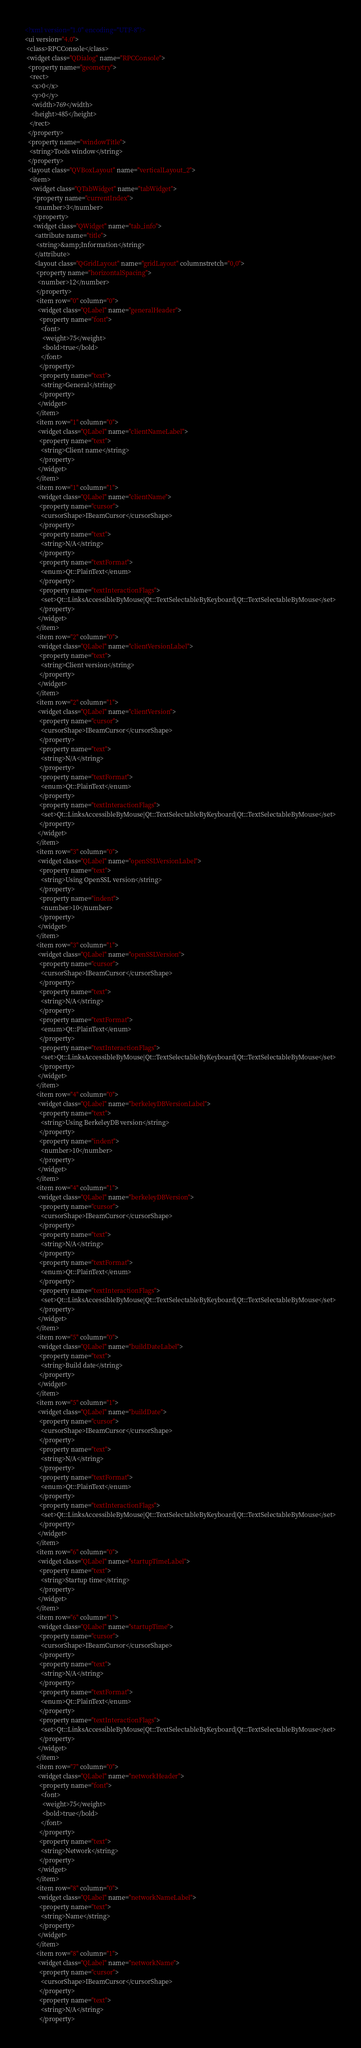<code> <loc_0><loc_0><loc_500><loc_500><_XML_><?xml version="1.0" encoding="UTF-8"?>
<ui version="4.0">
 <class>RPCConsole</class>
 <widget class="QDialog" name="RPCConsole">
  <property name="geometry">
   <rect>
    <x>0</x>
    <y>0</y>
    <width>769</width>
    <height>485</height>
   </rect>
  </property>
  <property name="windowTitle">
   <string>Tools window</string>
  </property>
  <layout class="QVBoxLayout" name="verticalLayout_2">
   <item>
    <widget class="QTabWidget" name="tabWidget">
     <property name="currentIndex">
      <number>3</number>
     </property>
     <widget class="QWidget" name="tab_info">
      <attribute name="title">
       <string>&amp;Information</string>
      </attribute>
      <layout class="QGridLayout" name="gridLayout" columnstretch="0,0">
       <property name="horizontalSpacing">
        <number>12</number>
       </property>
       <item row="0" column="0">
        <widget class="QLabel" name="generalHeader">
         <property name="font">
          <font>
           <weight>75</weight>
           <bold>true</bold>
          </font>
         </property>
         <property name="text">
          <string>General</string>
         </property>
        </widget>
       </item>
       <item row="1" column="0">
        <widget class="QLabel" name="clientNameLabel">
         <property name="text">
          <string>Client name</string>
         </property>
        </widget>
       </item>
       <item row="1" column="1">
        <widget class="QLabel" name="clientName">
         <property name="cursor">
          <cursorShape>IBeamCursor</cursorShape>
         </property>
         <property name="text">
          <string>N/A</string>
         </property>
         <property name="textFormat">
          <enum>Qt::PlainText</enum>
         </property>
         <property name="textInteractionFlags">
          <set>Qt::LinksAccessibleByMouse|Qt::TextSelectableByKeyboard|Qt::TextSelectableByMouse</set>
         </property>
        </widget>
       </item>
       <item row="2" column="0">
        <widget class="QLabel" name="clientVersionLabel">
         <property name="text">
          <string>Client version</string>
         </property>
        </widget>
       </item>
       <item row="2" column="1">
        <widget class="QLabel" name="clientVersion">
         <property name="cursor">
          <cursorShape>IBeamCursor</cursorShape>
         </property>
         <property name="text">
          <string>N/A</string>
         </property>
         <property name="textFormat">
          <enum>Qt::PlainText</enum>
         </property>
         <property name="textInteractionFlags">
          <set>Qt::LinksAccessibleByMouse|Qt::TextSelectableByKeyboard|Qt::TextSelectableByMouse</set>
         </property>
        </widget>
       </item>
       <item row="3" column="0">
        <widget class="QLabel" name="openSSLVersionLabel">
         <property name="text">
          <string>Using OpenSSL version</string>
         </property>
         <property name="indent">
          <number>10</number>
         </property>
        </widget>
       </item>
       <item row="3" column="1">
        <widget class="QLabel" name="openSSLVersion">
         <property name="cursor">
          <cursorShape>IBeamCursor</cursorShape>
         </property>
         <property name="text">
          <string>N/A</string>
         </property>
         <property name="textFormat">
          <enum>Qt::PlainText</enum>
         </property>
         <property name="textInteractionFlags">
          <set>Qt::LinksAccessibleByMouse|Qt::TextSelectableByKeyboard|Qt::TextSelectableByMouse</set>
         </property>
        </widget>
       </item>
       <item row="4" column="0">
        <widget class="QLabel" name="berkeleyDBVersionLabel">
         <property name="text">
          <string>Using BerkeleyDB version</string>
         </property>
         <property name="indent">
          <number>10</number>
         </property>
        </widget>
       </item>
       <item row="4" column="1">
        <widget class="QLabel" name="berkeleyDBVersion">
         <property name="cursor">
          <cursorShape>IBeamCursor</cursorShape>
         </property>
         <property name="text">
          <string>N/A</string>
         </property>
         <property name="textFormat">
          <enum>Qt::PlainText</enum>
         </property>
         <property name="textInteractionFlags">
          <set>Qt::LinksAccessibleByMouse|Qt::TextSelectableByKeyboard|Qt::TextSelectableByMouse</set>
         </property>
        </widget>
       </item>
       <item row="5" column="0">
        <widget class="QLabel" name="buildDateLabel">
         <property name="text">
          <string>Build date</string>
         </property>
        </widget>
       </item>
       <item row="5" column="1">
        <widget class="QLabel" name="buildDate">
         <property name="cursor">
          <cursorShape>IBeamCursor</cursorShape>
         </property>
         <property name="text">
          <string>N/A</string>
         </property>
         <property name="textFormat">
          <enum>Qt::PlainText</enum>
         </property>
         <property name="textInteractionFlags">
          <set>Qt::LinksAccessibleByMouse|Qt::TextSelectableByKeyboard|Qt::TextSelectableByMouse</set>
         </property>
        </widget>
       </item>
       <item row="6" column="0">
        <widget class="QLabel" name="startupTimeLabel">
         <property name="text">
          <string>Startup time</string>
         </property>
        </widget>
       </item>
       <item row="6" column="1">
        <widget class="QLabel" name="startupTime">
         <property name="cursor">
          <cursorShape>IBeamCursor</cursorShape>
         </property>
         <property name="text">
          <string>N/A</string>
         </property>
         <property name="textFormat">
          <enum>Qt::PlainText</enum>
         </property>
         <property name="textInteractionFlags">
          <set>Qt::LinksAccessibleByMouse|Qt::TextSelectableByKeyboard|Qt::TextSelectableByMouse</set>
         </property>
        </widget>
       </item>
       <item row="7" column="0">
        <widget class="QLabel" name="networkHeader">
         <property name="font">
          <font>
           <weight>75</weight>
           <bold>true</bold>
          </font>
         </property>
         <property name="text">
          <string>Network</string>
         </property>
        </widget>
       </item>
       <item row="8" column="0">
        <widget class="QLabel" name="networkNameLabel">
         <property name="text">
          <string>Name</string>
         </property>
        </widget>
       </item>
       <item row="8" column="1">
        <widget class="QLabel" name="networkName">
         <property name="cursor">
          <cursorShape>IBeamCursor</cursorShape>
         </property>
         <property name="text">
          <string>N/A</string>
         </property></code> 